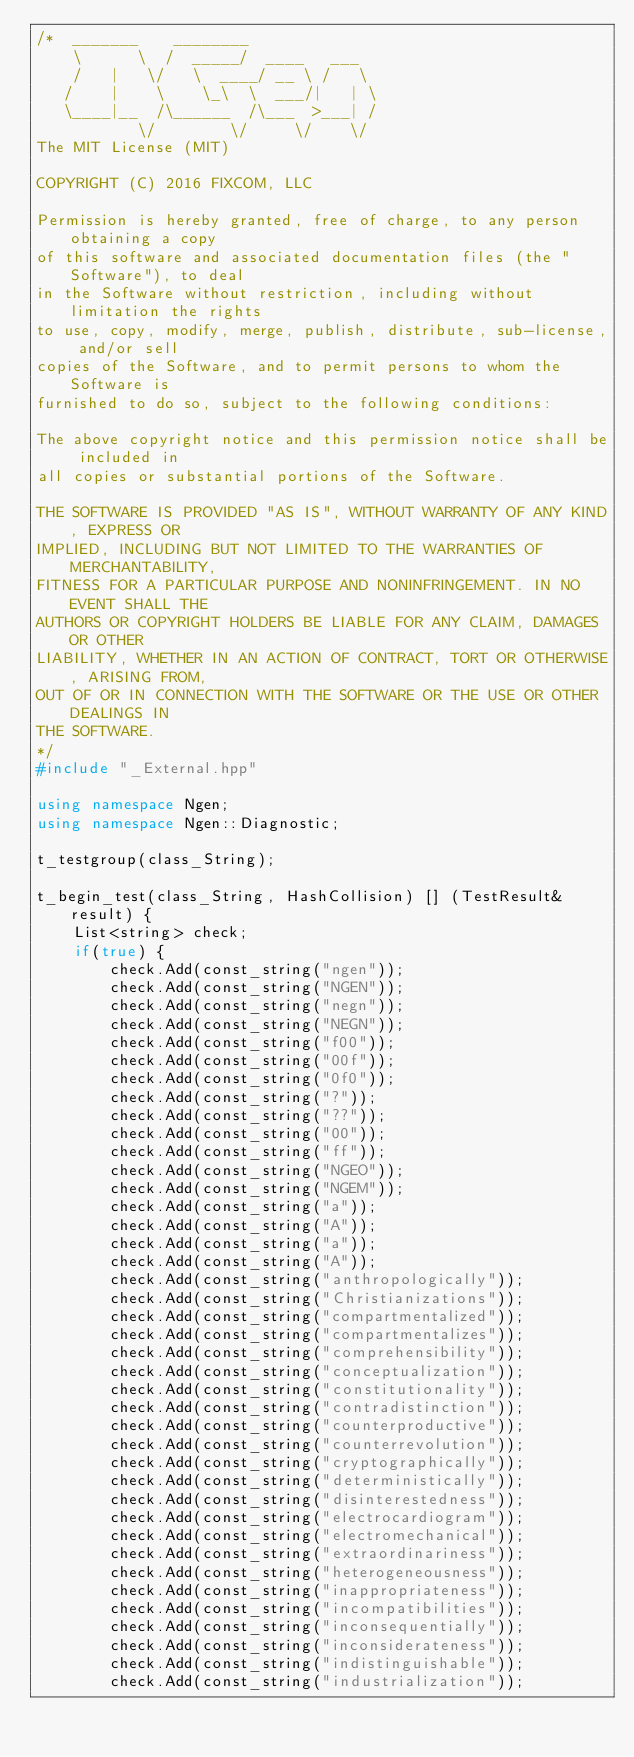Convert code to text. <code><loc_0><loc_0><loc_500><loc_500><_C++_>/*  _______    ________
    \      \  /  _____/  ____   ___
    /   |   \/   \  ____/ __ \ /   \
   /    |    \    \_\  \  ___/|   | \
   \____|__  /\______  /\___  >___| /
           \/        \/     \/    \/
The MIT License (MIT)

COPYRIGHT (C) 2016 FIXCOM, LLC

Permission is hereby granted, free of charge, to any person obtaining a copy
of this software and associated documentation files (the "Software"), to deal
in the Software without restriction, including without limitation the rights
to use, copy, modify, merge, publish, distribute, sub-license, and/or sell
copies of the Software, and to permit persons to whom the Software is
furnished to do so, subject to the following conditions:

The above copyright notice and this permission notice shall be included in
all copies or substantial portions of the Software.

THE SOFTWARE IS PROVIDED "AS IS", WITHOUT WARRANTY OF ANY KIND, EXPRESS OR
IMPLIED, INCLUDING BUT NOT LIMITED TO THE WARRANTIES OF MERCHANTABILITY,
FITNESS FOR A PARTICULAR PURPOSE AND NONINFRINGEMENT. IN NO EVENT SHALL THE
AUTHORS OR COPYRIGHT HOLDERS BE LIABLE FOR ANY CLAIM, DAMAGES OR OTHER
LIABILITY, WHETHER IN AN ACTION OF CONTRACT, TORT OR OTHERWISE, ARISING FROM,
OUT OF OR IN CONNECTION WITH THE SOFTWARE OR THE USE OR OTHER DEALINGS IN
THE SOFTWARE.
*/
#include "_External.hpp"

using namespace Ngen;
using namespace Ngen::Diagnostic;

t_testgroup(class_String);

t_begin_test(class_String, HashCollision) [] (TestResult& result) {
	List<string> check;
	if(true) {
		check.Add(const_string("ngen"));
		check.Add(const_string("NGEN"));
		check.Add(const_string("negn"));
		check.Add(const_string("NEGN"));
		check.Add(const_string("f00"));
		check.Add(const_string("00f"));
		check.Add(const_string("0f0"));
		check.Add(const_string("?"));
		check.Add(const_string("??"));
		check.Add(const_string("00"));
		check.Add(const_string("ff"));
		check.Add(const_string("NGEO"));
		check.Add(const_string("NGEM"));
		check.Add(const_string("a"));
		check.Add(const_string("A"));
		check.Add(const_string("a"));
		check.Add(const_string("A"));
		check.Add(const_string("anthropologically"));
		check.Add(const_string("Christianizations"));
		check.Add(const_string("compartmentalized"));
		check.Add(const_string("compartmentalizes"));
		check.Add(const_string("comprehensibility"));
		check.Add(const_string("conceptualization"));
		check.Add(const_string("constitutionality"));
		check.Add(const_string("contradistinction"));
		check.Add(const_string("counterproductive"));
		check.Add(const_string("counterrevolution"));
		check.Add(const_string("cryptographically"));
		check.Add(const_string("deterministically"));
		check.Add(const_string("disinterestedness"));
		check.Add(const_string("electrocardiogram"));
		check.Add(const_string("electromechanical"));
		check.Add(const_string("extraordinariness"));
		check.Add(const_string("heterogeneousness"));
		check.Add(const_string("inappropriateness"));
		check.Add(const_string("incompatibilities"));
		check.Add(const_string("inconsequentially"));
		check.Add(const_string("inconsiderateness"));
		check.Add(const_string("indistinguishable"));
		check.Add(const_string("industrialization"));</code> 